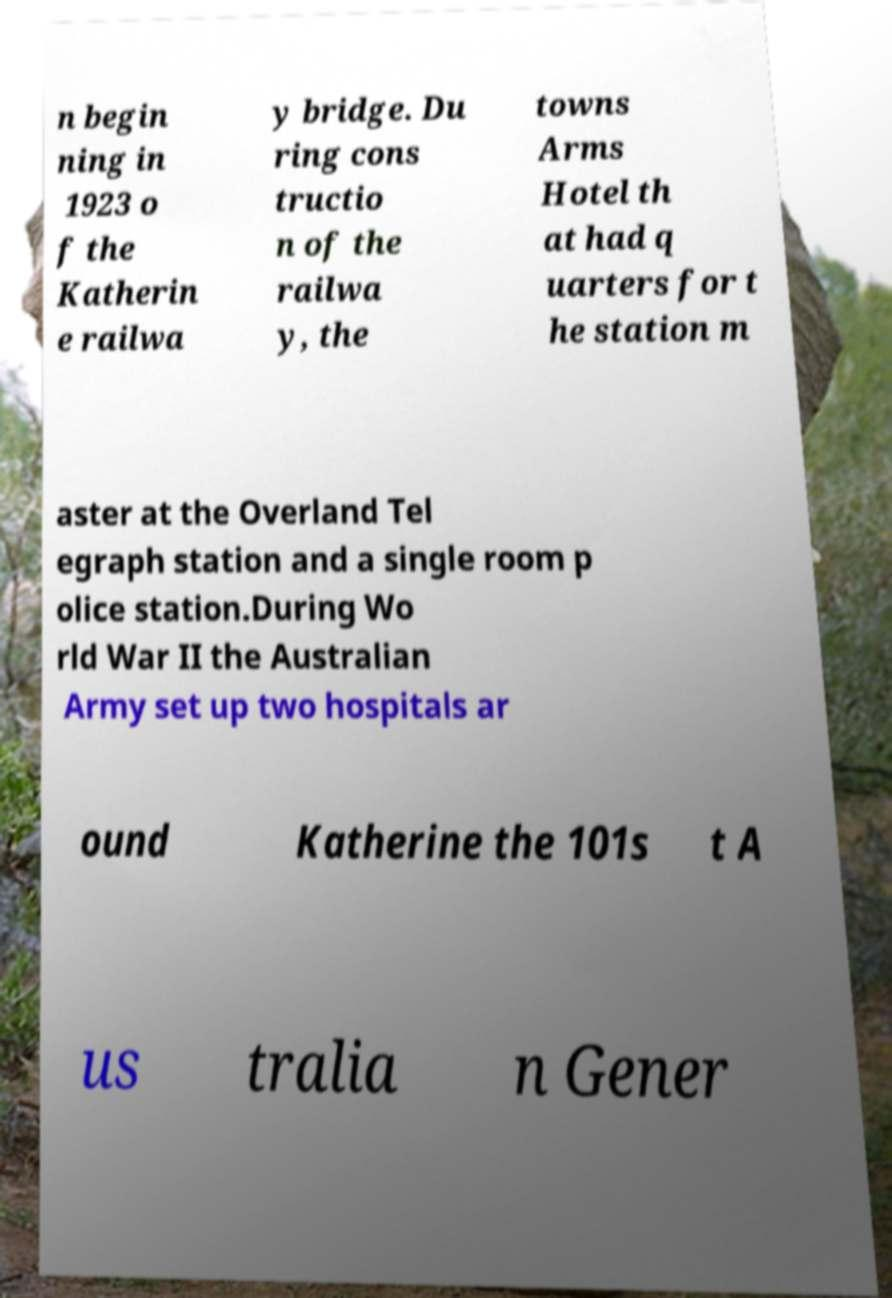Please read and relay the text visible in this image. What does it say? n begin ning in 1923 o f the Katherin e railwa y bridge. Du ring cons tructio n of the railwa y, the towns Arms Hotel th at had q uarters for t he station m aster at the Overland Tel egraph station and a single room p olice station.During Wo rld War II the Australian Army set up two hospitals ar ound Katherine the 101s t A us tralia n Gener 